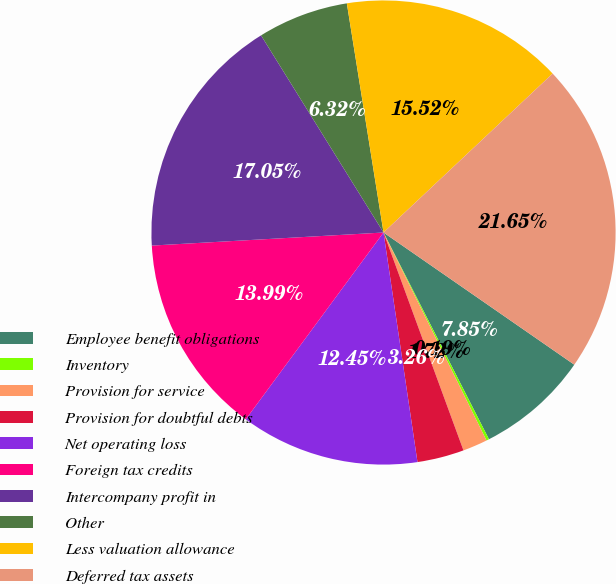Convert chart. <chart><loc_0><loc_0><loc_500><loc_500><pie_chart><fcel>Employee benefit obligations<fcel>Inventory<fcel>Provision for service<fcel>Provision for doubtful debts<fcel>Net operating loss<fcel>Foreign tax credits<fcel>Intercompany profit in<fcel>Other<fcel>Less valuation allowance<fcel>Deferred tax assets<nl><fcel>7.85%<fcel>0.19%<fcel>1.72%<fcel>3.26%<fcel>12.45%<fcel>13.99%<fcel>17.05%<fcel>6.32%<fcel>15.52%<fcel>21.65%<nl></chart> 